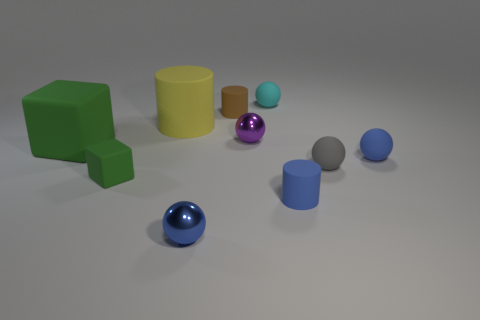Is the color of the small cube the same as the large matte cylinder?
Offer a terse response. No. Are there the same number of gray matte balls behind the small brown matte cylinder and tiny brown cylinders behind the tiny cyan thing?
Offer a very short reply. Yes. What color is the tiny ball in front of the small cylinder that is in front of the block that is left of the small rubber cube?
Provide a succinct answer. Blue. Is there anything else of the same color as the large cylinder?
Your response must be concise. No. What shape is the rubber thing that is the same color as the large rubber block?
Provide a succinct answer. Cube. There is a ball that is in front of the gray rubber ball; how big is it?
Provide a short and direct response. Small. What is the shape of the cyan thing that is the same size as the blue shiny ball?
Keep it short and to the point. Sphere. Do the large object in front of the yellow rubber object and the blue thing on the left side of the cyan object have the same material?
Give a very brief answer. No. There is a tiny blue sphere that is left of the rubber cylinder right of the brown matte thing; what is it made of?
Your answer should be compact. Metal. How big is the green rubber cube behind the blue sphere behind the blue ball that is to the left of the tiny cyan object?
Offer a very short reply. Large. 